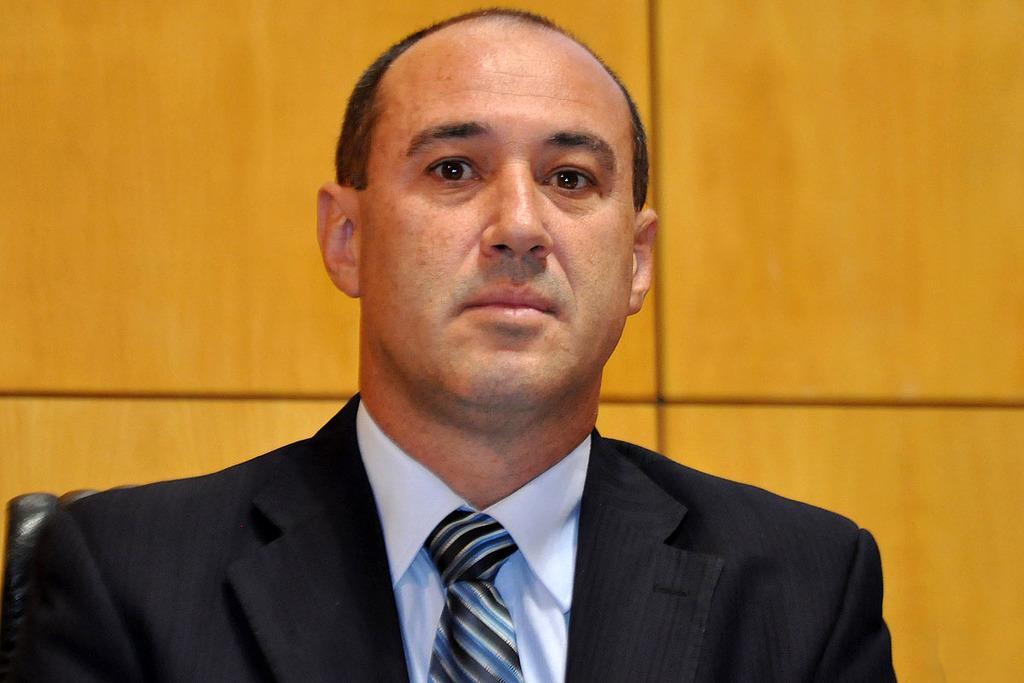Describe this image in one or two sentences. In this image we can see a person wearing a suit and a wall in the background. 